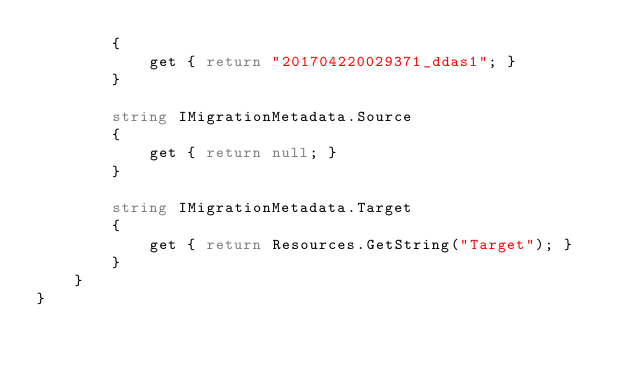Convert code to text. <code><loc_0><loc_0><loc_500><loc_500><_C#_>        {
            get { return "201704220029371_ddas1"; }
        }
        
        string IMigrationMetadata.Source
        {
            get { return null; }
        }
        
        string IMigrationMetadata.Target
        {
            get { return Resources.GetString("Target"); }
        }
    }
}
</code> 